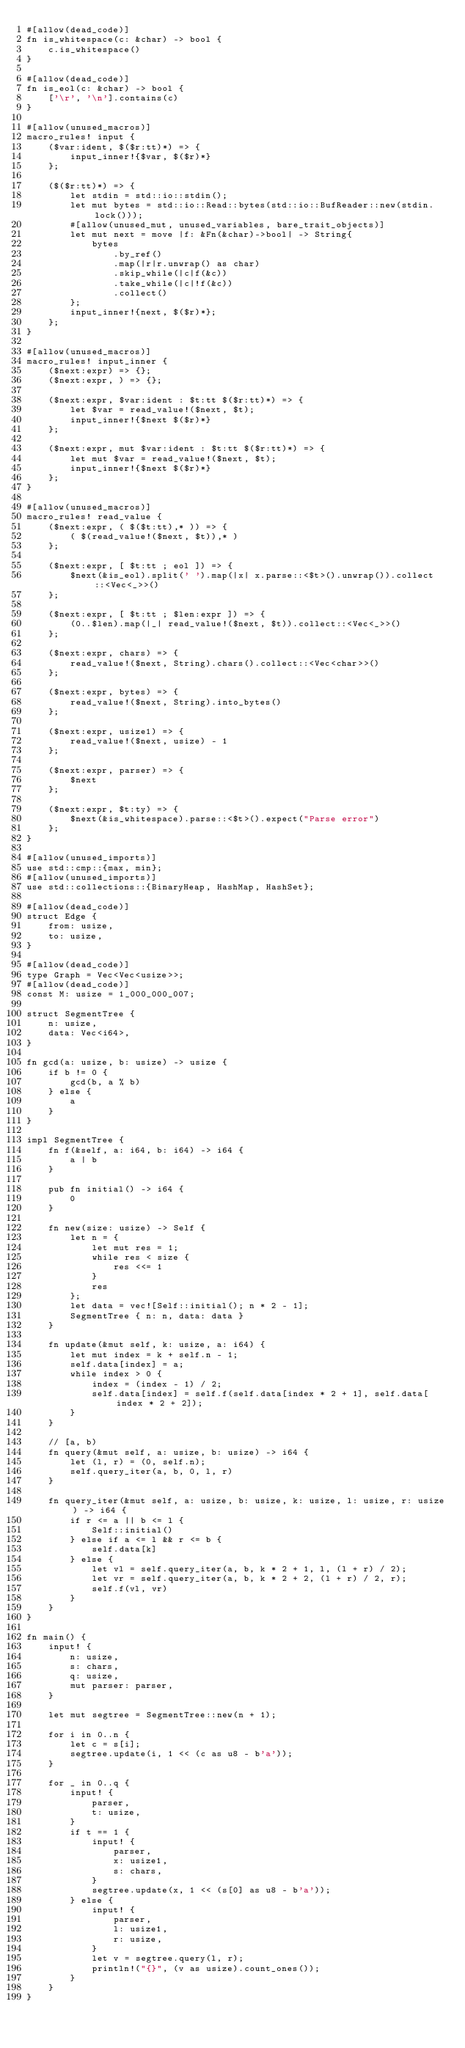<code> <loc_0><loc_0><loc_500><loc_500><_Rust_>#[allow(dead_code)]
fn is_whitespace(c: &char) -> bool {
    c.is_whitespace()
}

#[allow(dead_code)]
fn is_eol(c: &char) -> bool {
    ['\r', '\n'].contains(c)
}

#[allow(unused_macros)]
macro_rules! input {
    ($var:ident, $($r:tt)*) => {
        input_inner!{$var, $($r)*}
    };

    ($($r:tt)*) => {
        let stdin = std::io::stdin();
        let mut bytes = std::io::Read::bytes(std::io::BufReader::new(stdin.lock()));
        #[allow(unused_mut, unused_variables, bare_trait_objects)]
        let mut next = move |f: &Fn(&char)->bool| -> String{
            bytes
                .by_ref()
                .map(|r|r.unwrap() as char)
                .skip_while(|c|f(&c))
                .take_while(|c|!f(&c))
                .collect()
        };
        input_inner!{next, $($r)*};
    };
}

#[allow(unused_macros)]
macro_rules! input_inner {
    ($next:expr) => {};
    ($next:expr, ) => {};

    ($next:expr, $var:ident : $t:tt $($r:tt)*) => {
        let $var = read_value!($next, $t);
        input_inner!{$next $($r)*}
    };

    ($next:expr, mut $var:ident : $t:tt $($r:tt)*) => {
        let mut $var = read_value!($next, $t);
        input_inner!{$next $($r)*}
    };
}

#[allow(unused_macros)]
macro_rules! read_value {
    ($next:expr, ( $($t:tt),* )) => {
        ( $(read_value!($next, $t)),* )
    };

    ($next:expr, [ $t:tt ; eol ]) => {
        $next(&is_eol).split(' ').map(|x| x.parse::<$t>().unwrap()).collect::<Vec<_>>()
    };

    ($next:expr, [ $t:tt ; $len:expr ]) => {
        (0..$len).map(|_| read_value!($next, $t)).collect::<Vec<_>>()
    };

    ($next:expr, chars) => {
        read_value!($next, String).chars().collect::<Vec<char>>()
    };

    ($next:expr, bytes) => {
        read_value!($next, String).into_bytes()
    };

    ($next:expr, usize1) => {
        read_value!($next, usize) - 1
    };

    ($next:expr, parser) => {
        $next
    };

    ($next:expr, $t:ty) => {
        $next(&is_whitespace).parse::<$t>().expect("Parse error")
    };
}

#[allow(unused_imports)]
use std::cmp::{max, min};
#[allow(unused_imports)]
use std::collections::{BinaryHeap, HashMap, HashSet};

#[allow(dead_code)]
struct Edge {
    from: usize,
    to: usize,
}

#[allow(dead_code)]
type Graph = Vec<Vec<usize>>;
#[allow(dead_code)]
const M: usize = 1_000_000_007;

struct SegmentTree {
    n: usize,
    data: Vec<i64>,
}

fn gcd(a: usize, b: usize) -> usize {
    if b != 0 {
        gcd(b, a % b)
    } else {
        a
    }
}

impl SegmentTree {
    fn f(&self, a: i64, b: i64) -> i64 {
        a | b
    }

    pub fn initial() -> i64 {
        0
    }

    fn new(size: usize) -> Self {
        let n = {
            let mut res = 1;
            while res < size {
                res <<= 1
            }
            res
        };
        let data = vec![Self::initial(); n * 2 - 1];
        SegmentTree { n: n, data: data }
    }

    fn update(&mut self, k: usize, a: i64) {
        let mut index = k + self.n - 1;
        self.data[index] = a;
        while index > 0 {
            index = (index - 1) / 2;
            self.data[index] = self.f(self.data[index * 2 + 1], self.data[index * 2 + 2]);
        }
    }

    // [a, b)
    fn query(&mut self, a: usize, b: usize) -> i64 {
        let (l, r) = (0, self.n);
        self.query_iter(a, b, 0, l, r)
    }

    fn query_iter(&mut self, a: usize, b: usize, k: usize, l: usize, r: usize) -> i64 {
        if r <= a || b <= l {
            Self::initial()
        } else if a <= l && r <= b {
            self.data[k]
        } else {
            let vl = self.query_iter(a, b, k * 2 + 1, l, (l + r) / 2);
            let vr = self.query_iter(a, b, k * 2 + 2, (l + r) / 2, r);
            self.f(vl, vr)
        }
    }
}

fn main() {
    input! {
        n: usize,
        s: chars,
        q: usize,
        mut parser: parser,
    }

    let mut segtree = SegmentTree::new(n + 1);

    for i in 0..n {
        let c = s[i];
        segtree.update(i, 1 << (c as u8 - b'a'));
    }

    for _ in 0..q {
        input! {
            parser,
            t: usize,
        }
        if t == 1 {
            input! {
                parser,
                x: usize1,
                s: chars,
            }
            segtree.update(x, 1 << (s[0] as u8 - b'a'));
        } else {
            input! {
                parser,
                l: usize1,
                r: usize,
            }
            let v = segtree.query(l, r);
            println!("{}", (v as usize).count_ones());
        }
    }
}
</code> 